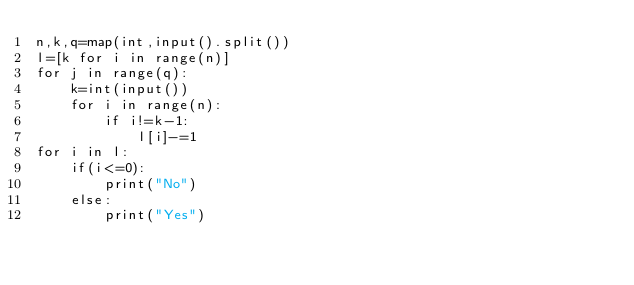Convert code to text. <code><loc_0><loc_0><loc_500><loc_500><_Python_>n,k,q=map(int,input().split())
l=[k for i in range(n)]
for j in range(q):
    k=int(input())
    for i in range(n):
        if i!=k-1:
            l[i]-=1
for i in l:
    if(i<=0):
        print("No")
    else:
        print("Yes")</code> 